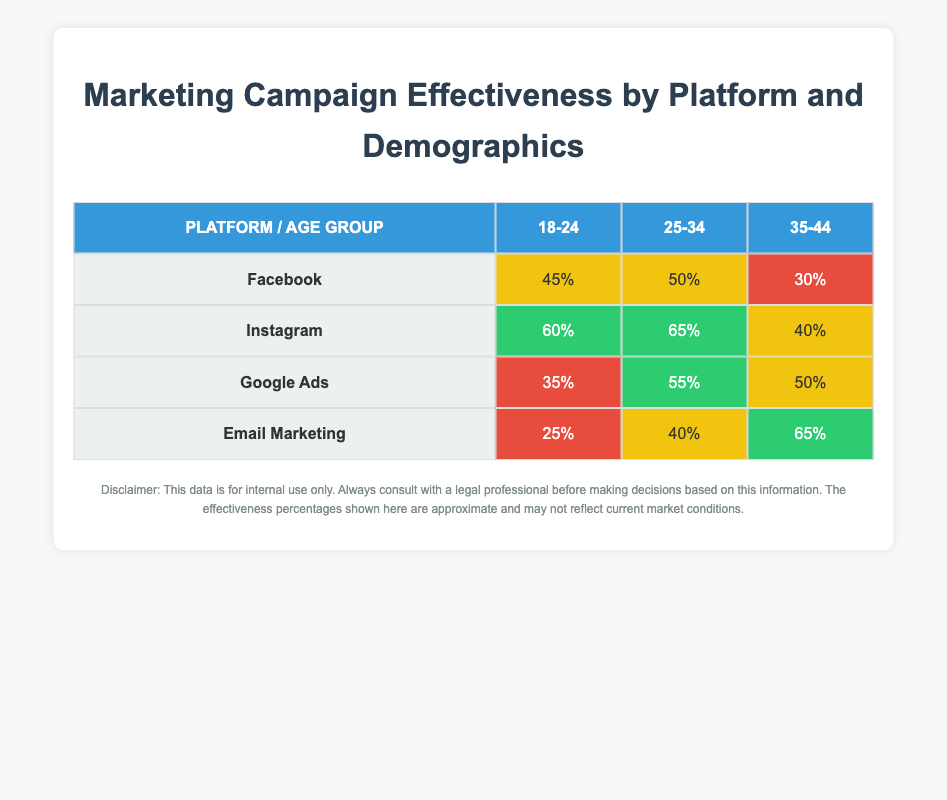What is the campaign effectiveness percentage for Facebook in the 25-34 age group? The table shows the effectiveness percentages for each platform and age group. For Facebook in the 25-34 category, the effectiveness percentage is listed as 50%.
Answer: 50% Which platform has the highest campaign effectiveness percentage for the 18-24 age group? By comparing the effectiveness percentages in the 18-24 age group across all platforms, Instagram has the highest percentage at 60%.
Answer: Instagram What is the average campaign effectiveness percentage across all platforms for the 35-44 age group? The effectiveness percentages for the 35-44 age group are: 30% (Facebook), 40% (Instagram), 50% (Google Ads), and 65% (Email Marketing). Summing these gives 30 + 40 + 50 + 65 = 185. There are 4 platforms, so the average is 185 / 4 = 46.25%.
Answer: 46.25% Is the campaign effectiveness percentage for Email Marketing better than that for Google Ads in the 25-34 age group? For Email Marketing, the effectiveness is 40%, and for Google Ads, it is 55%. Since 40% < 55%, it can be concluded that Email Marketing is not better than Google Ads in this age group.
Answer: No What is the difference in campaign effectiveness percentages for the 25-34 age group between Instagram and Facebook? For Instagram in the 25-34 age group, the effectiveness percentage is 65%, and for Facebook, it is 50%. The difference is 65 - 50 = 15%.
Answer: 15% Which age demographic has the lowest campaign effectiveness percentage for Google Ads? Looking at the table, the effectiveness percentages for Google Ads are 35% (18-24), 55% (25-34), and 50% (35-44). The lowest percentage is for the 18-24 age demographic at 35%.
Answer: 18-24 Is it true that the effectiveness for Email Marketing in the 35-44 age group is higher than that for Facebook in the same age group? For Email Marketing, the effectiveness is 65%, while for Facebook it is 30%. Since 65% > 30%, it is true that Email Marketing has a higher effectiveness.
Answer: Yes What is the total campaign effectiveness percentage for all platforms in the 18-24 age group? The effectiveness percentages for the 18-24 age group are: 45% (Facebook), 60% (Instagram), 35% (Google Ads), and 25% (Email Marketing). Adding these values gives 45 + 60 + 35 + 25 = 165%.
Answer: 165% 